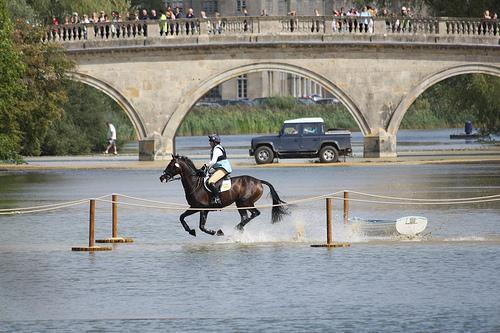How many horses are there?
Give a very brief answer. 1. 